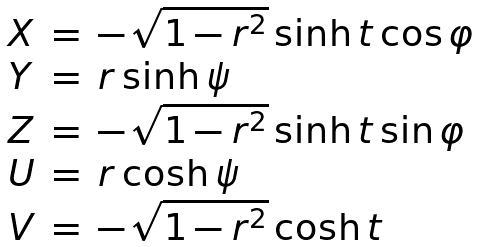<formula> <loc_0><loc_0><loc_500><loc_500>\begin{array} { l l l } X & = & - \sqrt { 1 - r ^ { 2 } } \sinh t \cos \varphi \\ Y & = & r \sinh \psi \\ Z & = & - \sqrt { 1 - r ^ { 2 } } \sinh t \sin \varphi \\ U & = & r \cosh \psi \\ V & = & - \sqrt { 1 - r ^ { 2 } } \cosh t \end{array}</formula> 